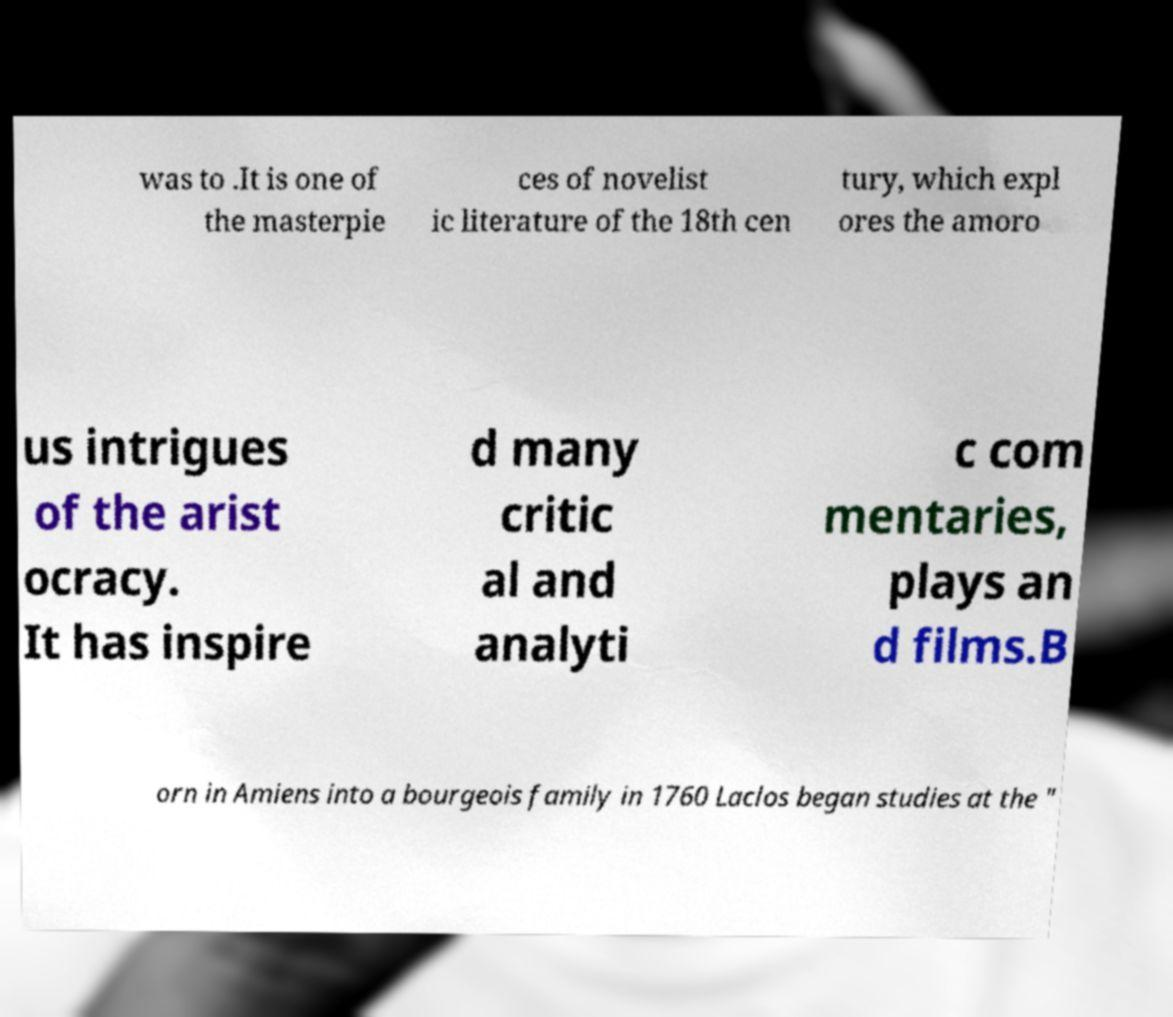There's text embedded in this image that I need extracted. Can you transcribe it verbatim? was to .It is one of the masterpie ces of novelist ic literature of the 18th cen tury, which expl ores the amoro us intrigues of the arist ocracy. It has inspire d many critic al and analyti c com mentaries, plays an d films.B orn in Amiens into a bourgeois family in 1760 Laclos began studies at the " 